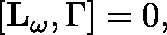Convert formula to latex. <formula><loc_0><loc_0><loc_500><loc_500>[ L _ { \omega } , \Gamma ] = 0 ,</formula> 